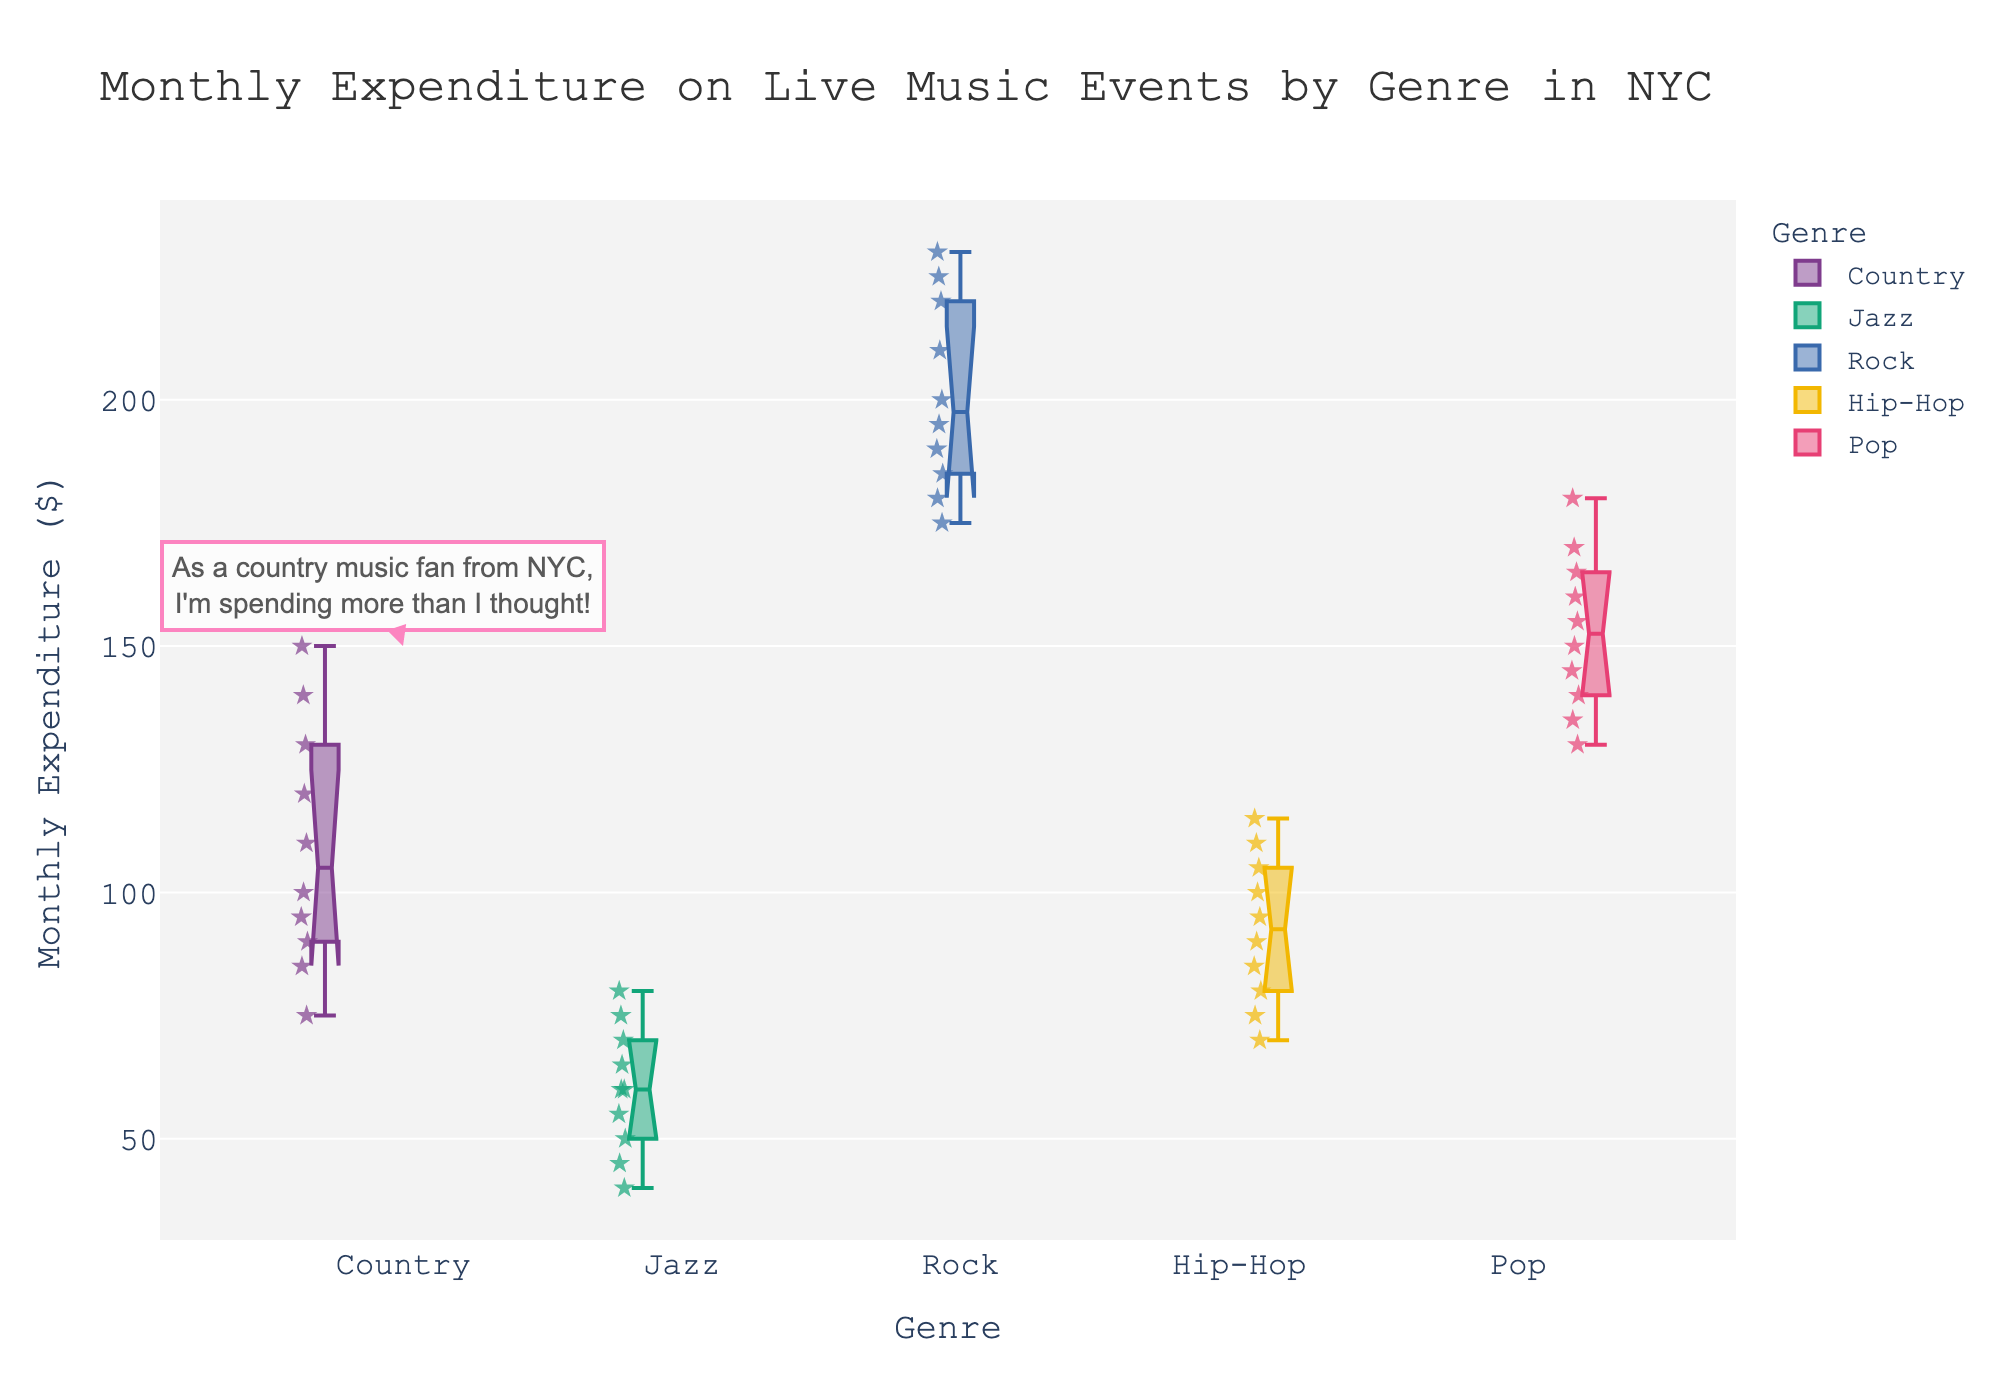What is the title of the plot? The title is located at the top of the chart and provides an overview of the data being visualized. It helps in understanding the context of the figure before diving into the details.
Answer: Monthly Expenditure on Live Music Events by Genre in NYC Which genre has the highest median monthly expenditure for live music events? The median in a notched box plot is depicted by the line inside the box. Identifying the highest median requires comparing the position of the median lines across all genres.
Answer: Rock What is the range of monthly expenditures for Pop music? The range in a box plot is indicated by the distance between the bottom whisker (minimum expenditure) and the top whisker (maximum expenditure). For Pop music, compare the bottom and top whiskers.
Answer: 130 - 180 Which genre has the widest interquartile range (IQR)? The IQR is represented by the length of the box in a notched box plot, which indicates the middle 50% of the data. To find the widest IQR, compare the lengths of the boxes across all genres.
Answer: Rock Are there any outliers in the Jazz genre? In a box plot, outliers are shown as individual points outside the whiskers. Check for any points that appear separately from the main distribution in the Jazz genre.
Answer: No What is the approximate median monthly expenditure for Country music? The median is the line within the Country music box. Estimating its value involves examining its position on the y-axis.
Answer: Around 110 How does the median expenditure on Jazz compare to the median expenditure on Hip-Hop? To compare the medians, identify the line within the boxes for Jazz and Hip-Hop and compare their positions along the y-axis.
Answer: Jazz's median is lower than Hip-Hop's Which genre has the least variability in monthly expenditures? Variability can be inferred from the width of the box and length of the whiskers. The genre with the smallest box and shortest whiskers has the least variability.
Answer: Jazz What is the most you could spend on monthly live music events for Rock music? The maximum expenditure value is indicated by the top whisker in the Rock music box plot.
Answer: 230 How many data points are displayed for each genre? The data points are shown as individual markers within each genre's box plot. Count the number of star symbols (data points) for each genre.
Answer: 10 per genre 